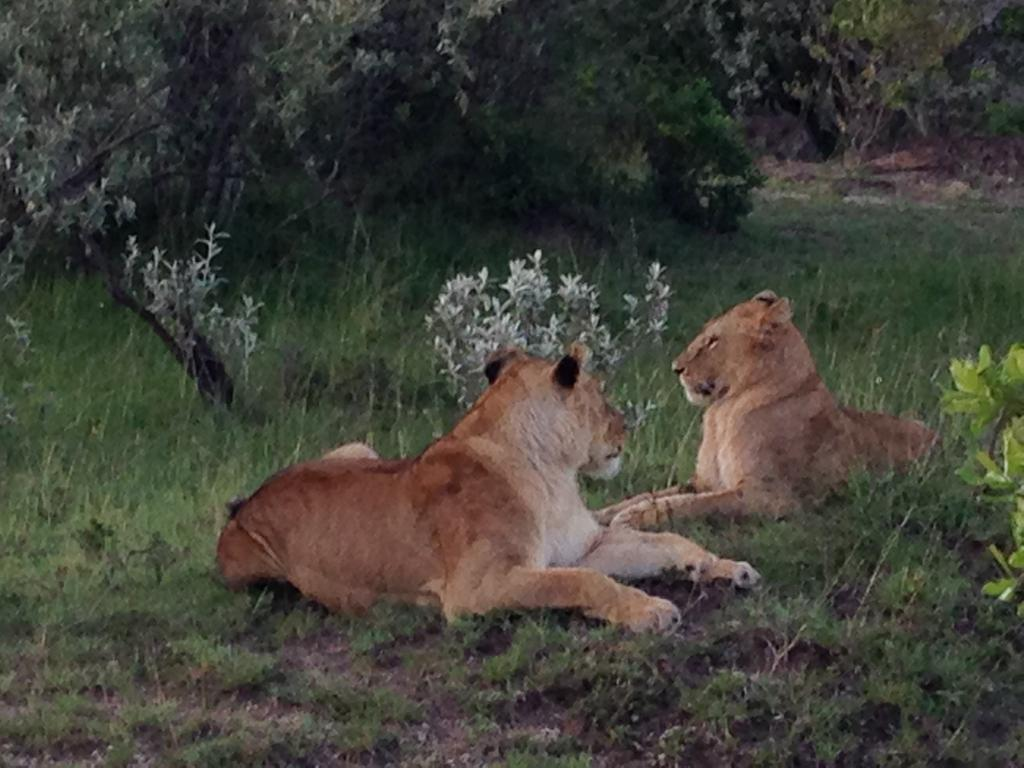How many lions can be seen in the image? There are two lions in the image. What type of vegetation is present in the image? There are many plants and trees visible in the image. What type of ground cover is visible in the image? There is grass visible in the image. What can be seen in the background of the image? There are many trees in the background of the image. What type of needle can be seen in the image? There is no needle present in the image. What type of pain is being experienced by the lions in the image? There is no indication of pain being experienced by the lions in the image. 